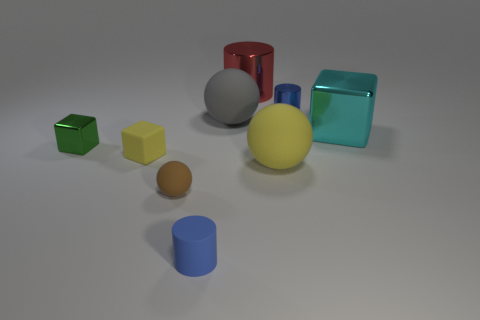Subtract all green metal blocks. How many blocks are left? 2 Subtract all brown balls. How many blue cylinders are left? 2 Subtract all green cubes. How many cubes are left? 2 Subtract 1 cylinders. How many cylinders are left? 2 Add 8 small cyan metal spheres. How many small cyan metal spheres exist? 8 Subtract 1 cyan blocks. How many objects are left? 8 Subtract all blocks. How many objects are left? 6 Subtract all green cylinders. Subtract all red cubes. How many cylinders are left? 3 Subtract all small matte blocks. Subtract all metallic things. How many objects are left? 4 Add 4 small metallic cylinders. How many small metallic cylinders are left? 5 